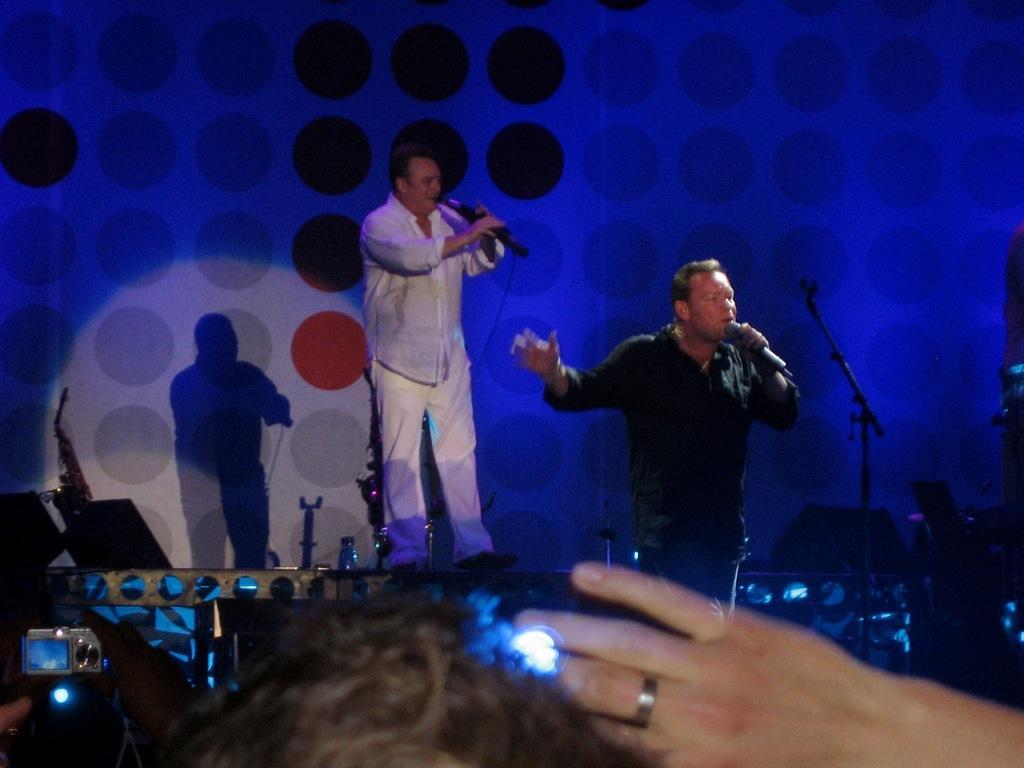How would you summarize this image in a sentence or two? In this image, we can see two men standing and holding the microphones, we can see the blue color light and there is a shadow of the man on the wall. 